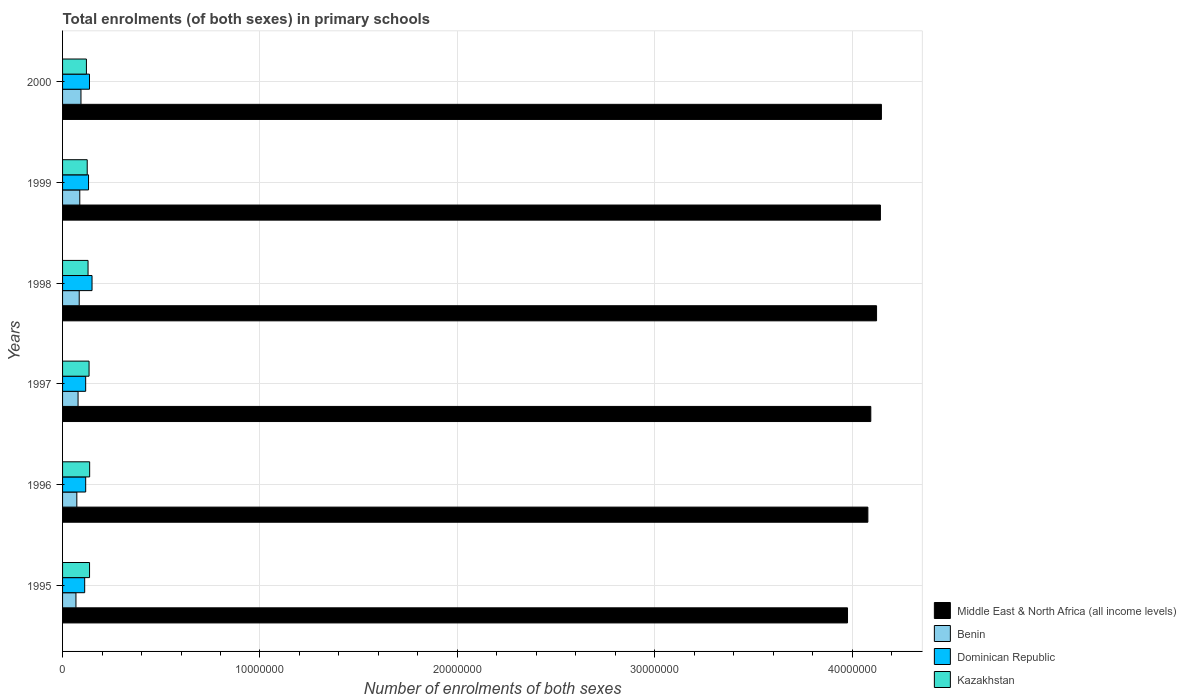How many different coloured bars are there?
Provide a succinct answer. 4. Are the number of bars per tick equal to the number of legend labels?
Give a very brief answer. Yes. How many bars are there on the 1st tick from the bottom?
Keep it short and to the point. 4. What is the label of the 6th group of bars from the top?
Make the answer very short. 1995. In how many cases, is the number of bars for a given year not equal to the number of legend labels?
Offer a terse response. 0. What is the number of enrolments in primary schools in Middle East & North Africa (all income levels) in 1999?
Ensure brevity in your answer.  4.14e+07. Across all years, what is the maximum number of enrolments in primary schools in Kazakhstan?
Offer a very short reply. 1.37e+06. Across all years, what is the minimum number of enrolments in primary schools in Dominican Republic?
Provide a succinct answer. 1.12e+06. What is the total number of enrolments in primary schools in Dominican Republic in the graph?
Give a very brief answer. 7.63e+06. What is the difference between the number of enrolments in primary schools in Middle East & North Africa (all income levels) in 1999 and that in 2000?
Your answer should be compact. -5.08e+04. What is the difference between the number of enrolments in primary schools in Middle East & North Africa (all income levels) in 1995 and the number of enrolments in primary schools in Kazakhstan in 1997?
Make the answer very short. 3.84e+07. What is the average number of enrolments in primary schools in Dominican Republic per year?
Provide a succinct answer. 1.27e+06. In the year 2000, what is the difference between the number of enrolments in primary schools in Dominican Republic and number of enrolments in primary schools in Benin?
Offer a very short reply. 4.31e+05. In how many years, is the number of enrolments in primary schools in Benin greater than 30000000 ?
Your answer should be very brief. 0. What is the ratio of the number of enrolments in primary schools in Kazakhstan in 1998 to that in 1999?
Give a very brief answer. 1.03. What is the difference between the highest and the second highest number of enrolments in primary schools in Kazakhstan?
Your answer should be very brief. 5534. What is the difference between the highest and the lowest number of enrolments in primary schools in Kazakhstan?
Your answer should be very brief. 1.64e+05. Is it the case that in every year, the sum of the number of enrolments in primary schools in Dominican Republic and number of enrolments in primary schools in Middle East & North Africa (all income levels) is greater than the sum of number of enrolments in primary schools in Kazakhstan and number of enrolments in primary schools in Benin?
Offer a very short reply. Yes. What does the 1st bar from the top in 2000 represents?
Offer a terse response. Kazakhstan. What does the 3rd bar from the bottom in 1999 represents?
Keep it short and to the point. Dominican Republic. Is it the case that in every year, the sum of the number of enrolments in primary schools in Benin and number of enrolments in primary schools in Dominican Republic is greater than the number of enrolments in primary schools in Middle East & North Africa (all income levels)?
Offer a terse response. No. What is the difference between two consecutive major ticks on the X-axis?
Your response must be concise. 1.00e+07. Are the values on the major ticks of X-axis written in scientific E-notation?
Make the answer very short. No. Does the graph contain any zero values?
Give a very brief answer. No. Does the graph contain grids?
Offer a terse response. Yes. How are the legend labels stacked?
Your answer should be compact. Vertical. What is the title of the graph?
Provide a succinct answer. Total enrolments (of both sexes) in primary schools. Does "Senegal" appear as one of the legend labels in the graph?
Keep it short and to the point. No. What is the label or title of the X-axis?
Make the answer very short. Number of enrolments of both sexes. What is the label or title of the Y-axis?
Ensure brevity in your answer.  Years. What is the Number of enrolments of both sexes of Middle East & North Africa (all income levels) in 1995?
Your answer should be very brief. 3.98e+07. What is the Number of enrolments of both sexes in Benin in 1995?
Your response must be concise. 6.78e+05. What is the Number of enrolments of both sexes in Dominican Republic in 1995?
Offer a very short reply. 1.12e+06. What is the Number of enrolments of both sexes in Kazakhstan in 1995?
Offer a terse response. 1.37e+06. What is the Number of enrolments of both sexes in Middle East & North Africa (all income levels) in 1996?
Your answer should be very brief. 4.08e+07. What is the Number of enrolments of both sexes of Benin in 1996?
Offer a very short reply. 7.22e+05. What is the Number of enrolments of both sexes of Dominican Republic in 1996?
Give a very brief answer. 1.17e+06. What is the Number of enrolments of both sexes in Kazakhstan in 1996?
Make the answer very short. 1.37e+06. What is the Number of enrolments of both sexes of Middle East & North Africa (all income levels) in 1997?
Your answer should be compact. 4.09e+07. What is the Number of enrolments of both sexes in Benin in 1997?
Your answer should be compact. 7.85e+05. What is the Number of enrolments of both sexes of Dominican Republic in 1997?
Provide a short and direct response. 1.17e+06. What is the Number of enrolments of both sexes in Kazakhstan in 1997?
Provide a succinct answer. 1.34e+06. What is the Number of enrolments of both sexes of Middle East & North Africa (all income levels) in 1998?
Ensure brevity in your answer.  4.12e+07. What is the Number of enrolments of both sexes of Benin in 1998?
Offer a terse response. 8.43e+05. What is the Number of enrolments of both sexes of Dominican Republic in 1998?
Keep it short and to the point. 1.49e+06. What is the Number of enrolments of both sexes of Kazakhstan in 1998?
Offer a terse response. 1.29e+06. What is the Number of enrolments of both sexes of Middle East & North Africa (all income levels) in 1999?
Offer a terse response. 4.14e+07. What is the Number of enrolments of both sexes of Benin in 1999?
Offer a terse response. 8.72e+05. What is the Number of enrolments of both sexes of Dominican Republic in 1999?
Your answer should be compact. 1.32e+06. What is the Number of enrolments of both sexes in Kazakhstan in 1999?
Your response must be concise. 1.25e+06. What is the Number of enrolments of both sexes of Middle East & North Africa (all income levels) in 2000?
Your response must be concise. 4.15e+07. What is the Number of enrolments of both sexes in Benin in 2000?
Offer a very short reply. 9.32e+05. What is the Number of enrolments of both sexes of Dominican Republic in 2000?
Make the answer very short. 1.36e+06. What is the Number of enrolments of both sexes in Kazakhstan in 2000?
Give a very brief answer. 1.21e+06. Across all years, what is the maximum Number of enrolments of both sexes of Middle East & North Africa (all income levels)?
Offer a terse response. 4.15e+07. Across all years, what is the maximum Number of enrolments of both sexes in Benin?
Your answer should be compact. 9.32e+05. Across all years, what is the maximum Number of enrolments of both sexes in Dominican Republic?
Your response must be concise. 1.49e+06. Across all years, what is the maximum Number of enrolments of both sexes of Kazakhstan?
Your response must be concise. 1.37e+06. Across all years, what is the minimum Number of enrolments of both sexes in Middle East & North Africa (all income levels)?
Ensure brevity in your answer.  3.98e+07. Across all years, what is the minimum Number of enrolments of both sexes in Benin?
Provide a short and direct response. 6.78e+05. Across all years, what is the minimum Number of enrolments of both sexes in Dominican Republic?
Give a very brief answer. 1.12e+06. Across all years, what is the minimum Number of enrolments of both sexes in Kazakhstan?
Offer a very short reply. 1.21e+06. What is the total Number of enrolments of both sexes of Middle East & North Africa (all income levels) in the graph?
Make the answer very short. 2.46e+08. What is the total Number of enrolments of both sexes in Benin in the graph?
Provide a short and direct response. 4.83e+06. What is the total Number of enrolments of both sexes of Dominican Republic in the graph?
Provide a succinct answer. 7.63e+06. What is the total Number of enrolments of both sexes in Kazakhstan in the graph?
Provide a short and direct response. 7.83e+06. What is the difference between the Number of enrolments of both sexes of Middle East & North Africa (all income levels) in 1995 and that in 1996?
Your answer should be compact. -1.03e+06. What is the difference between the Number of enrolments of both sexes of Benin in 1995 and that in 1996?
Ensure brevity in your answer.  -4.43e+04. What is the difference between the Number of enrolments of both sexes of Dominican Republic in 1995 and that in 1996?
Make the answer very short. -5.05e+04. What is the difference between the Number of enrolments of both sexes in Kazakhstan in 1995 and that in 1996?
Make the answer very short. -5534. What is the difference between the Number of enrolments of both sexes of Middle East & North Africa (all income levels) in 1995 and that in 1997?
Provide a short and direct response. -1.18e+06. What is the difference between the Number of enrolments of both sexes in Benin in 1995 and that in 1997?
Provide a succinct answer. -1.07e+05. What is the difference between the Number of enrolments of both sexes in Dominican Republic in 1995 and that in 1997?
Offer a terse response. -4.94e+04. What is the difference between the Number of enrolments of both sexes in Kazakhstan in 1995 and that in 1997?
Offer a terse response. 2.50e+04. What is the difference between the Number of enrolments of both sexes in Middle East & North Africa (all income levels) in 1995 and that in 1998?
Provide a succinct answer. -1.47e+06. What is the difference between the Number of enrolments of both sexes of Benin in 1995 and that in 1998?
Offer a terse response. -1.65e+05. What is the difference between the Number of enrolments of both sexes in Dominican Republic in 1995 and that in 1998?
Provide a short and direct response. -3.72e+05. What is the difference between the Number of enrolments of both sexes in Kazakhstan in 1995 and that in 1998?
Your answer should be compact. 7.63e+04. What is the difference between the Number of enrolments of both sexes of Middle East & North Africa (all income levels) in 1995 and that in 1999?
Your response must be concise. -1.67e+06. What is the difference between the Number of enrolments of both sexes of Benin in 1995 and that in 1999?
Give a very brief answer. -1.94e+05. What is the difference between the Number of enrolments of both sexes in Dominican Republic in 1995 and that in 1999?
Provide a short and direct response. -1.94e+05. What is the difference between the Number of enrolments of both sexes of Kazakhstan in 1995 and that in 1999?
Offer a very short reply. 1.18e+05. What is the difference between the Number of enrolments of both sexes of Middle East & North Africa (all income levels) in 1995 and that in 2000?
Your answer should be compact. -1.72e+06. What is the difference between the Number of enrolments of both sexes in Benin in 1995 and that in 2000?
Offer a very short reply. -2.55e+05. What is the difference between the Number of enrolments of both sexes in Dominican Republic in 1995 and that in 2000?
Provide a short and direct response. -2.43e+05. What is the difference between the Number of enrolments of both sexes of Kazakhstan in 1995 and that in 2000?
Keep it short and to the point. 1.59e+05. What is the difference between the Number of enrolments of both sexes in Middle East & North Africa (all income levels) in 1996 and that in 1997?
Ensure brevity in your answer.  -1.48e+05. What is the difference between the Number of enrolments of both sexes of Benin in 1996 and that in 1997?
Your answer should be compact. -6.27e+04. What is the difference between the Number of enrolments of both sexes of Dominican Republic in 1996 and that in 1997?
Offer a terse response. 1073. What is the difference between the Number of enrolments of both sexes of Kazakhstan in 1996 and that in 1997?
Ensure brevity in your answer.  3.06e+04. What is the difference between the Number of enrolments of both sexes in Middle East & North Africa (all income levels) in 1996 and that in 1998?
Your answer should be compact. -4.40e+05. What is the difference between the Number of enrolments of both sexes of Benin in 1996 and that in 1998?
Ensure brevity in your answer.  -1.21e+05. What is the difference between the Number of enrolments of both sexes of Dominican Republic in 1996 and that in 1998?
Keep it short and to the point. -3.21e+05. What is the difference between the Number of enrolments of both sexes of Kazakhstan in 1996 and that in 1998?
Keep it short and to the point. 8.18e+04. What is the difference between the Number of enrolments of both sexes of Middle East & North Africa (all income levels) in 1996 and that in 1999?
Make the answer very short. -6.35e+05. What is the difference between the Number of enrolments of both sexes of Benin in 1996 and that in 1999?
Your response must be concise. -1.50e+05. What is the difference between the Number of enrolments of both sexes in Dominican Republic in 1996 and that in 1999?
Offer a very short reply. -1.44e+05. What is the difference between the Number of enrolments of both sexes of Kazakhstan in 1996 and that in 1999?
Provide a succinct answer. 1.24e+05. What is the difference between the Number of enrolments of both sexes in Middle East & North Africa (all income levels) in 1996 and that in 2000?
Your answer should be very brief. -6.86e+05. What is the difference between the Number of enrolments of both sexes of Benin in 1996 and that in 2000?
Provide a short and direct response. -2.10e+05. What is the difference between the Number of enrolments of both sexes of Dominican Republic in 1996 and that in 2000?
Make the answer very short. -1.92e+05. What is the difference between the Number of enrolments of both sexes in Kazakhstan in 1996 and that in 2000?
Your response must be concise. 1.64e+05. What is the difference between the Number of enrolments of both sexes of Middle East & North Africa (all income levels) in 1997 and that in 1998?
Ensure brevity in your answer.  -2.92e+05. What is the difference between the Number of enrolments of both sexes in Benin in 1997 and that in 1998?
Ensure brevity in your answer.  -5.85e+04. What is the difference between the Number of enrolments of both sexes in Dominican Republic in 1997 and that in 1998?
Your response must be concise. -3.22e+05. What is the difference between the Number of enrolments of both sexes in Kazakhstan in 1997 and that in 1998?
Offer a very short reply. 5.12e+04. What is the difference between the Number of enrolments of both sexes of Middle East & North Africa (all income levels) in 1997 and that in 1999?
Make the answer very short. -4.87e+05. What is the difference between the Number of enrolments of both sexes in Benin in 1997 and that in 1999?
Make the answer very short. -8.73e+04. What is the difference between the Number of enrolments of both sexes of Dominican Republic in 1997 and that in 1999?
Offer a terse response. -1.45e+05. What is the difference between the Number of enrolments of both sexes of Kazakhstan in 1997 and that in 1999?
Your response must be concise. 9.31e+04. What is the difference between the Number of enrolments of both sexes of Middle East & North Africa (all income levels) in 1997 and that in 2000?
Provide a short and direct response. -5.38e+05. What is the difference between the Number of enrolments of both sexes in Benin in 1997 and that in 2000?
Provide a succinct answer. -1.48e+05. What is the difference between the Number of enrolments of both sexes of Dominican Republic in 1997 and that in 2000?
Make the answer very short. -1.93e+05. What is the difference between the Number of enrolments of both sexes in Kazakhstan in 1997 and that in 2000?
Ensure brevity in your answer.  1.34e+05. What is the difference between the Number of enrolments of both sexes of Middle East & North Africa (all income levels) in 1998 and that in 1999?
Provide a succinct answer. -1.95e+05. What is the difference between the Number of enrolments of both sexes in Benin in 1998 and that in 1999?
Give a very brief answer. -2.89e+04. What is the difference between the Number of enrolments of both sexes in Dominican Republic in 1998 and that in 1999?
Your response must be concise. 1.77e+05. What is the difference between the Number of enrolments of both sexes in Kazakhstan in 1998 and that in 1999?
Make the answer very short. 4.19e+04. What is the difference between the Number of enrolments of both sexes of Middle East & North Africa (all income levels) in 1998 and that in 2000?
Provide a short and direct response. -2.46e+05. What is the difference between the Number of enrolments of both sexes in Benin in 1998 and that in 2000?
Keep it short and to the point. -8.91e+04. What is the difference between the Number of enrolments of both sexes in Dominican Republic in 1998 and that in 2000?
Provide a short and direct response. 1.29e+05. What is the difference between the Number of enrolments of both sexes in Kazakhstan in 1998 and that in 2000?
Your answer should be compact. 8.25e+04. What is the difference between the Number of enrolments of both sexes of Middle East & North Africa (all income levels) in 1999 and that in 2000?
Your answer should be compact. -5.08e+04. What is the difference between the Number of enrolments of both sexes in Benin in 1999 and that in 2000?
Offer a terse response. -6.02e+04. What is the difference between the Number of enrolments of both sexes in Dominican Republic in 1999 and that in 2000?
Provide a short and direct response. -4.83e+04. What is the difference between the Number of enrolments of both sexes in Kazakhstan in 1999 and that in 2000?
Keep it short and to the point. 4.06e+04. What is the difference between the Number of enrolments of both sexes of Middle East & North Africa (all income levels) in 1995 and the Number of enrolments of both sexes of Benin in 1996?
Offer a terse response. 3.90e+07. What is the difference between the Number of enrolments of both sexes in Middle East & North Africa (all income levels) in 1995 and the Number of enrolments of both sexes in Dominican Republic in 1996?
Offer a very short reply. 3.86e+07. What is the difference between the Number of enrolments of both sexes of Middle East & North Africa (all income levels) in 1995 and the Number of enrolments of both sexes of Kazakhstan in 1996?
Provide a short and direct response. 3.84e+07. What is the difference between the Number of enrolments of both sexes in Benin in 1995 and the Number of enrolments of both sexes in Dominican Republic in 1996?
Your answer should be compact. -4.94e+05. What is the difference between the Number of enrolments of both sexes of Benin in 1995 and the Number of enrolments of both sexes of Kazakhstan in 1996?
Provide a short and direct response. -6.95e+05. What is the difference between the Number of enrolments of both sexes in Dominican Republic in 1995 and the Number of enrolments of both sexes in Kazakhstan in 1996?
Keep it short and to the point. -2.52e+05. What is the difference between the Number of enrolments of both sexes of Middle East & North Africa (all income levels) in 1995 and the Number of enrolments of both sexes of Benin in 1997?
Your response must be concise. 3.90e+07. What is the difference between the Number of enrolments of both sexes in Middle East & North Africa (all income levels) in 1995 and the Number of enrolments of both sexes in Dominican Republic in 1997?
Provide a short and direct response. 3.86e+07. What is the difference between the Number of enrolments of both sexes of Middle East & North Africa (all income levels) in 1995 and the Number of enrolments of both sexes of Kazakhstan in 1997?
Your response must be concise. 3.84e+07. What is the difference between the Number of enrolments of both sexes of Benin in 1995 and the Number of enrolments of both sexes of Dominican Republic in 1997?
Provide a succinct answer. -4.93e+05. What is the difference between the Number of enrolments of both sexes of Benin in 1995 and the Number of enrolments of both sexes of Kazakhstan in 1997?
Give a very brief answer. -6.64e+05. What is the difference between the Number of enrolments of both sexes of Dominican Republic in 1995 and the Number of enrolments of both sexes of Kazakhstan in 1997?
Offer a terse response. -2.21e+05. What is the difference between the Number of enrolments of both sexes in Middle East & North Africa (all income levels) in 1995 and the Number of enrolments of both sexes in Benin in 1998?
Make the answer very short. 3.89e+07. What is the difference between the Number of enrolments of both sexes of Middle East & North Africa (all income levels) in 1995 and the Number of enrolments of both sexes of Dominican Republic in 1998?
Provide a short and direct response. 3.83e+07. What is the difference between the Number of enrolments of both sexes in Middle East & North Africa (all income levels) in 1995 and the Number of enrolments of both sexes in Kazakhstan in 1998?
Ensure brevity in your answer.  3.85e+07. What is the difference between the Number of enrolments of both sexes in Benin in 1995 and the Number of enrolments of both sexes in Dominican Republic in 1998?
Keep it short and to the point. -8.15e+05. What is the difference between the Number of enrolments of both sexes of Benin in 1995 and the Number of enrolments of both sexes of Kazakhstan in 1998?
Offer a very short reply. -6.13e+05. What is the difference between the Number of enrolments of both sexes in Dominican Republic in 1995 and the Number of enrolments of both sexes in Kazakhstan in 1998?
Give a very brief answer. -1.70e+05. What is the difference between the Number of enrolments of both sexes of Middle East & North Africa (all income levels) in 1995 and the Number of enrolments of both sexes of Benin in 1999?
Make the answer very short. 3.89e+07. What is the difference between the Number of enrolments of both sexes in Middle East & North Africa (all income levels) in 1995 and the Number of enrolments of both sexes in Dominican Republic in 1999?
Offer a very short reply. 3.84e+07. What is the difference between the Number of enrolments of both sexes of Middle East & North Africa (all income levels) in 1995 and the Number of enrolments of both sexes of Kazakhstan in 1999?
Provide a short and direct response. 3.85e+07. What is the difference between the Number of enrolments of both sexes of Benin in 1995 and the Number of enrolments of both sexes of Dominican Republic in 1999?
Make the answer very short. -6.37e+05. What is the difference between the Number of enrolments of both sexes in Benin in 1995 and the Number of enrolments of both sexes in Kazakhstan in 1999?
Your answer should be compact. -5.71e+05. What is the difference between the Number of enrolments of both sexes in Dominican Republic in 1995 and the Number of enrolments of both sexes in Kazakhstan in 1999?
Your answer should be very brief. -1.28e+05. What is the difference between the Number of enrolments of both sexes in Middle East & North Africa (all income levels) in 1995 and the Number of enrolments of both sexes in Benin in 2000?
Provide a succinct answer. 3.88e+07. What is the difference between the Number of enrolments of both sexes of Middle East & North Africa (all income levels) in 1995 and the Number of enrolments of both sexes of Dominican Republic in 2000?
Your answer should be very brief. 3.84e+07. What is the difference between the Number of enrolments of both sexes of Middle East & North Africa (all income levels) in 1995 and the Number of enrolments of both sexes of Kazakhstan in 2000?
Keep it short and to the point. 3.86e+07. What is the difference between the Number of enrolments of both sexes of Benin in 1995 and the Number of enrolments of both sexes of Dominican Republic in 2000?
Provide a short and direct response. -6.86e+05. What is the difference between the Number of enrolments of both sexes in Benin in 1995 and the Number of enrolments of both sexes in Kazakhstan in 2000?
Your answer should be very brief. -5.30e+05. What is the difference between the Number of enrolments of both sexes of Dominican Republic in 1995 and the Number of enrolments of both sexes of Kazakhstan in 2000?
Your response must be concise. -8.73e+04. What is the difference between the Number of enrolments of both sexes in Middle East & North Africa (all income levels) in 1996 and the Number of enrolments of both sexes in Benin in 1997?
Give a very brief answer. 4.00e+07. What is the difference between the Number of enrolments of both sexes in Middle East & North Africa (all income levels) in 1996 and the Number of enrolments of both sexes in Dominican Republic in 1997?
Provide a succinct answer. 3.96e+07. What is the difference between the Number of enrolments of both sexes in Middle East & North Africa (all income levels) in 1996 and the Number of enrolments of both sexes in Kazakhstan in 1997?
Provide a short and direct response. 3.95e+07. What is the difference between the Number of enrolments of both sexes in Benin in 1996 and the Number of enrolments of both sexes in Dominican Republic in 1997?
Give a very brief answer. -4.48e+05. What is the difference between the Number of enrolments of both sexes in Benin in 1996 and the Number of enrolments of both sexes in Kazakhstan in 1997?
Your answer should be compact. -6.20e+05. What is the difference between the Number of enrolments of both sexes in Dominican Republic in 1996 and the Number of enrolments of both sexes in Kazakhstan in 1997?
Make the answer very short. -1.71e+05. What is the difference between the Number of enrolments of both sexes of Middle East & North Africa (all income levels) in 1996 and the Number of enrolments of both sexes of Benin in 1998?
Ensure brevity in your answer.  4.00e+07. What is the difference between the Number of enrolments of both sexes of Middle East & North Africa (all income levels) in 1996 and the Number of enrolments of both sexes of Dominican Republic in 1998?
Your response must be concise. 3.93e+07. What is the difference between the Number of enrolments of both sexes of Middle East & North Africa (all income levels) in 1996 and the Number of enrolments of both sexes of Kazakhstan in 1998?
Your answer should be very brief. 3.95e+07. What is the difference between the Number of enrolments of both sexes in Benin in 1996 and the Number of enrolments of both sexes in Dominican Republic in 1998?
Make the answer very short. -7.70e+05. What is the difference between the Number of enrolments of both sexes of Benin in 1996 and the Number of enrolments of both sexes of Kazakhstan in 1998?
Offer a very short reply. -5.69e+05. What is the difference between the Number of enrolments of both sexes in Dominican Republic in 1996 and the Number of enrolments of both sexes in Kazakhstan in 1998?
Provide a succinct answer. -1.19e+05. What is the difference between the Number of enrolments of both sexes of Middle East & North Africa (all income levels) in 1996 and the Number of enrolments of both sexes of Benin in 1999?
Offer a very short reply. 3.99e+07. What is the difference between the Number of enrolments of both sexes in Middle East & North Africa (all income levels) in 1996 and the Number of enrolments of both sexes in Dominican Republic in 1999?
Provide a succinct answer. 3.95e+07. What is the difference between the Number of enrolments of both sexes of Middle East & North Africa (all income levels) in 1996 and the Number of enrolments of both sexes of Kazakhstan in 1999?
Provide a succinct answer. 3.95e+07. What is the difference between the Number of enrolments of both sexes of Benin in 1996 and the Number of enrolments of both sexes of Dominican Republic in 1999?
Provide a short and direct response. -5.93e+05. What is the difference between the Number of enrolments of both sexes in Benin in 1996 and the Number of enrolments of both sexes in Kazakhstan in 1999?
Provide a succinct answer. -5.27e+05. What is the difference between the Number of enrolments of both sexes in Dominican Republic in 1996 and the Number of enrolments of both sexes in Kazakhstan in 1999?
Your response must be concise. -7.74e+04. What is the difference between the Number of enrolments of both sexes in Middle East & North Africa (all income levels) in 1996 and the Number of enrolments of both sexes in Benin in 2000?
Provide a succinct answer. 3.99e+07. What is the difference between the Number of enrolments of both sexes of Middle East & North Africa (all income levels) in 1996 and the Number of enrolments of both sexes of Dominican Republic in 2000?
Give a very brief answer. 3.94e+07. What is the difference between the Number of enrolments of both sexes in Middle East & North Africa (all income levels) in 1996 and the Number of enrolments of both sexes in Kazakhstan in 2000?
Give a very brief answer. 3.96e+07. What is the difference between the Number of enrolments of both sexes of Benin in 1996 and the Number of enrolments of both sexes of Dominican Republic in 2000?
Your response must be concise. -6.41e+05. What is the difference between the Number of enrolments of both sexes of Benin in 1996 and the Number of enrolments of both sexes of Kazakhstan in 2000?
Your answer should be very brief. -4.86e+05. What is the difference between the Number of enrolments of both sexes in Dominican Republic in 1996 and the Number of enrolments of both sexes in Kazakhstan in 2000?
Your answer should be compact. -3.68e+04. What is the difference between the Number of enrolments of both sexes of Middle East & North Africa (all income levels) in 1997 and the Number of enrolments of both sexes of Benin in 1998?
Give a very brief answer. 4.01e+07. What is the difference between the Number of enrolments of both sexes of Middle East & North Africa (all income levels) in 1997 and the Number of enrolments of both sexes of Dominican Republic in 1998?
Give a very brief answer. 3.95e+07. What is the difference between the Number of enrolments of both sexes of Middle East & North Africa (all income levels) in 1997 and the Number of enrolments of both sexes of Kazakhstan in 1998?
Make the answer very short. 3.97e+07. What is the difference between the Number of enrolments of both sexes of Benin in 1997 and the Number of enrolments of both sexes of Dominican Republic in 1998?
Your response must be concise. -7.08e+05. What is the difference between the Number of enrolments of both sexes of Benin in 1997 and the Number of enrolments of both sexes of Kazakhstan in 1998?
Ensure brevity in your answer.  -5.06e+05. What is the difference between the Number of enrolments of both sexes in Dominican Republic in 1997 and the Number of enrolments of both sexes in Kazakhstan in 1998?
Offer a very short reply. -1.20e+05. What is the difference between the Number of enrolments of both sexes in Middle East & North Africa (all income levels) in 1997 and the Number of enrolments of both sexes in Benin in 1999?
Provide a short and direct response. 4.01e+07. What is the difference between the Number of enrolments of both sexes in Middle East & North Africa (all income levels) in 1997 and the Number of enrolments of both sexes in Dominican Republic in 1999?
Provide a succinct answer. 3.96e+07. What is the difference between the Number of enrolments of both sexes of Middle East & North Africa (all income levels) in 1997 and the Number of enrolments of both sexes of Kazakhstan in 1999?
Your answer should be compact. 3.97e+07. What is the difference between the Number of enrolments of both sexes in Benin in 1997 and the Number of enrolments of both sexes in Dominican Republic in 1999?
Provide a succinct answer. -5.30e+05. What is the difference between the Number of enrolments of both sexes in Benin in 1997 and the Number of enrolments of both sexes in Kazakhstan in 1999?
Your answer should be compact. -4.64e+05. What is the difference between the Number of enrolments of both sexes in Dominican Republic in 1997 and the Number of enrolments of both sexes in Kazakhstan in 1999?
Your answer should be very brief. -7.85e+04. What is the difference between the Number of enrolments of both sexes in Middle East & North Africa (all income levels) in 1997 and the Number of enrolments of both sexes in Benin in 2000?
Keep it short and to the point. 4.00e+07. What is the difference between the Number of enrolments of both sexes in Middle East & North Africa (all income levels) in 1997 and the Number of enrolments of both sexes in Dominican Republic in 2000?
Your response must be concise. 3.96e+07. What is the difference between the Number of enrolments of both sexes in Middle East & North Africa (all income levels) in 1997 and the Number of enrolments of both sexes in Kazakhstan in 2000?
Give a very brief answer. 3.97e+07. What is the difference between the Number of enrolments of both sexes in Benin in 1997 and the Number of enrolments of both sexes in Dominican Republic in 2000?
Provide a short and direct response. -5.79e+05. What is the difference between the Number of enrolments of both sexes in Benin in 1997 and the Number of enrolments of both sexes in Kazakhstan in 2000?
Your answer should be very brief. -4.23e+05. What is the difference between the Number of enrolments of both sexes in Dominican Republic in 1997 and the Number of enrolments of both sexes in Kazakhstan in 2000?
Provide a succinct answer. -3.79e+04. What is the difference between the Number of enrolments of both sexes in Middle East & North Africa (all income levels) in 1998 and the Number of enrolments of both sexes in Benin in 1999?
Your response must be concise. 4.04e+07. What is the difference between the Number of enrolments of both sexes of Middle East & North Africa (all income levels) in 1998 and the Number of enrolments of both sexes of Dominican Republic in 1999?
Make the answer very short. 3.99e+07. What is the difference between the Number of enrolments of both sexes of Middle East & North Africa (all income levels) in 1998 and the Number of enrolments of both sexes of Kazakhstan in 1999?
Make the answer very short. 4.00e+07. What is the difference between the Number of enrolments of both sexes of Benin in 1998 and the Number of enrolments of both sexes of Dominican Republic in 1999?
Provide a succinct answer. -4.72e+05. What is the difference between the Number of enrolments of both sexes in Benin in 1998 and the Number of enrolments of both sexes in Kazakhstan in 1999?
Keep it short and to the point. -4.06e+05. What is the difference between the Number of enrolments of both sexes of Dominican Republic in 1998 and the Number of enrolments of both sexes of Kazakhstan in 1999?
Provide a short and direct response. 2.44e+05. What is the difference between the Number of enrolments of both sexes of Middle East & North Africa (all income levels) in 1998 and the Number of enrolments of both sexes of Benin in 2000?
Make the answer very short. 4.03e+07. What is the difference between the Number of enrolments of both sexes of Middle East & North Africa (all income levels) in 1998 and the Number of enrolments of both sexes of Dominican Republic in 2000?
Ensure brevity in your answer.  3.99e+07. What is the difference between the Number of enrolments of both sexes in Middle East & North Africa (all income levels) in 1998 and the Number of enrolments of both sexes in Kazakhstan in 2000?
Make the answer very short. 4.00e+07. What is the difference between the Number of enrolments of both sexes in Benin in 1998 and the Number of enrolments of both sexes in Dominican Republic in 2000?
Provide a short and direct response. -5.20e+05. What is the difference between the Number of enrolments of both sexes of Benin in 1998 and the Number of enrolments of both sexes of Kazakhstan in 2000?
Provide a short and direct response. -3.65e+05. What is the difference between the Number of enrolments of both sexes of Dominican Republic in 1998 and the Number of enrolments of both sexes of Kazakhstan in 2000?
Make the answer very short. 2.84e+05. What is the difference between the Number of enrolments of both sexes in Middle East & North Africa (all income levels) in 1999 and the Number of enrolments of both sexes in Benin in 2000?
Provide a succinct answer. 4.05e+07. What is the difference between the Number of enrolments of both sexes in Middle East & North Africa (all income levels) in 1999 and the Number of enrolments of both sexes in Dominican Republic in 2000?
Keep it short and to the point. 4.01e+07. What is the difference between the Number of enrolments of both sexes of Middle East & North Africa (all income levels) in 1999 and the Number of enrolments of both sexes of Kazakhstan in 2000?
Offer a very short reply. 4.02e+07. What is the difference between the Number of enrolments of both sexes in Benin in 1999 and the Number of enrolments of both sexes in Dominican Republic in 2000?
Ensure brevity in your answer.  -4.91e+05. What is the difference between the Number of enrolments of both sexes of Benin in 1999 and the Number of enrolments of both sexes of Kazakhstan in 2000?
Your answer should be compact. -3.36e+05. What is the difference between the Number of enrolments of both sexes of Dominican Republic in 1999 and the Number of enrolments of both sexes of Kazakhstan in 2000?
Your answer should be compact. 1.07e+05. What is the average Number of enrolments of both sexes in Middle East & North Africa (all income levels) per year?
Offer a terse response. 4.09e+07. What is the average Number of enrolments of both sexes in Benin per year?
Your answer should be very brief. 8.05e+05. What is the average Number of enrolments of both sexes of Dominican Republic per year?
Provide a short and direct response. 1.27e+06. What is the average Number of enrolments of both sexes of Kazakhstan per year?
Keep it short and to the point. 1.30e+06. In the year 1995, what is the difference between the Number of enrolments of both sexes in Middle East & North Africa (all income levels) and Number of enrolments of both sexes in Benin?
Provide a succinct answer. 3.91e+07. In the year 1995, what is the difference between the Number of enrolments of both sexes in Middle East & North Africa (all income levels) and Number of enrolments of both sexes in Dominican Republic?
Offer a very short reply. 3.86e+07. In the year 1995, what is the difference between the Number of enrolments of both sexes in Middle East & North Africa (all income levels) and Number of enrolments of both sexes in Kazakhstan?
Offer a terse response. 3.84e+07. In the year 1995, what is the difference between the Number of enrolments of both sexes of Benin and Number of enrolments of both sexes of Dominican Republic?
Offer a very short reply. -4.43e+05. In the year 1995, what is the difference between the Number of enrolments of both sexes of Benin and Number of enrolments of both sexes of Kazakhstan?
Your answer should be very brief. -6.89e+05. In the year 1995, what is the difference between the Number of enrolments of both sexes in Dominican Republic and Number of enrolments of both sexes in Kazakhstan?
Ensure brevity in your answer.  -2.46e+05. In the year 1996, what is the difference between the Number of enrolments of both sexes of Middle East & North Africa (all income levels) and Number of enrolments of both sexes of Benin?
Offer a terse response. 4.01e+07. In the year 1996, what is the difference between the Number of enrolments of both sexes in Middle East & North Africa (all income levels) and Number of enrolments of both sexes in Dominican Republic?
Make the answer very short. 3.96e+07. In the year 1996, what is the difference between the Number of enrolments of both sexes of Middle East & North Africa (all income levels) and Number of enrolments of both sexes of Kazakhstan?
Provide a succinct answer. 3.94e+07. In the year 1996, what is the difference between the Number of enrolments of both sexes of Benin and Number of enrolments of both sexes of Dominican Republic?
Keep it short and to the point. -4.49e+05. In the year 1996, what is the difference between the Number of enrolments of both sexes of Benin and Number of enrolments of both sexes of Kazakhstan?
Your response must be concise. -6.50e+05. In the year 1996, what is the difference between the Number of enrolments of both sexes of Dominican Republic and Number of enrolments of both sexes of Kazakhstan?
Your answer should be compact. -2.01e+05. In the year 1997, what is the difference between the Number of enrolments of both sexes of Middle East & North Africa (all income levels) and Number of enrolments of both sexes of Benin?
Provide a succinct answer. 4.02e+07. In the year 1997, what is the difference between the Number of enrolments of both sexes of Middle East & North Africa (all income levels) and Number of enrolments of both sexes of Dominican Republic?
Provide a succinct answer. 3.98e+07. In the year 1997, what is the difference between the Number of enrolments of both sexes in Middle East & North Africa (all income levels) and Number of enrolments of both sexes in Kazakhstan?
Your answer should be very brief. 3.96e+07. In the year 1997, what is the difference between the Number of enrolments of both sexes in Benin and Number of enrolments of both sexes in Dominican Republic?
Your answer should be compact. -3.86e+05. In the year 1997, what is the difference between the Number of enrolments of both sexes in Benin and Number of enrolments of both sexes in Kazakhstan?
Your answer should be very brief. -5.57e+05. In the year 1997, what is the difference between the Number of enrolments of both sexes in Dominican Republic and Number of enrolments of both sexes in Kazakhstan?
Ensure brevity in your answer.  -1.72e+05. In the year 1998, what is the difference between the Number of enrolments of both sexes of Middle East & North Africa (all income levels) and Number of enrolments of both sexes of Benin?
Offer a terse response. 4.04e+07. In the year 1998, what is the difference between the Number of enrolments of both sexes in Middle East & North Africa (all income levels) and Number of enrolments of both sexes in Dominican Republic?
Your answer should be very brief. 3.97e+07. In the year 1998, what is the difference between the Number of enrolments of both sexes in Middle East & North Africa (all income levels) and Number of enrolments of both sexes in Kazakhstan?
Give a very brief answer. 3.99e+07. In the year 1998, what is the difference between the Number of enrolments of both sexes in Benin and Number of enrolments of both sexes in Dominican Republic?
Your answer should be compact. -6.49e+05. In the year 1998, what is the difference between the Number of enrolments of both sexes in Benin and Number of enrolments of both sexes in Kazakhstan?
Your response must be concise. -4.47e+05. In the year 1998, what is the difference between the Number of enrolments of both sexes in Dominican Republic and Number of enrolments of both sexes in Kazakhstan?
Your answer should be compact. 2.02e+05. In the year 1999, what is the difference between the Number of enrolments of both sexes in Middle East & North Africa (all income levels) and Number of enrolments of both sexes in Benin?
Offer a terse response. 4.06e+07. In the year 1999, what is the difference between the Number of enrolments of both sexes of Middle East & North Africa (all income levels) and Number of enrolments of both sexes of Dominican Republic?
Give a very brief answer. 4.01e+07. In the year 1999, what is the difference between the Number of enrolments of both sexes of Middle East & North Africa (all income levels) and Number of enrolments of both sexes of Kazakhstan?
Your answer should be very brief. 4.02e+07. In the year 1999, what is the difference between the Number of enrolments of both sexes in Benin and Number of enrolments of both sexes in Dominican Republic?
Your response must be concise. -4.43e+05. In the year 1999, what is the difference between the Number of enrolments of both sexes of Benin and Number of enrolments of both sexes of Kazakhstan?
Ensure brevity in your answer.  -3.77e+05. In the year 1999, what is the difference between the Number of enrolments of both sexes of Dominican Republic and Number of enrolments of both sexes of Kazakhstan?
Offer a very short reply. 6.64e+04. In the year 2000, what is the difference between the Number of enrolments of both sexes in Middle East & North Africa (all income levels) and Number of enrolments of both sexes in Benin?
Provide a succinct answer. 4.05e+07. In the year 2000, what is the difference between the Number of enrolments of both sexes of Middle East & North Africa (all income levels) and Number of enrolments of both sexes of Dominican Republic?
Your answer should be very brief. 4.01e+07. In the year 2000, what is the difference between the Number of enrolments of both sexes in Middle East & North Africa (all income levels) and Number of enrolments of both sexes in Kazakhstan?
Your answer should be very brief. 4.03e+07. In the year 2000, what is the difference between the Number of enrolments of both sexes in Benin and Number of enrolments of both sexes in Dominican Republic?
Provide a short and direct response. -4.31e+05. In the year 2000, what is the difference between the Number of enrolments of both sexes in Benin and Number of enrolments of both sexes in Kazakhstan?
Offer a very short reply. -2.76e+05. In the year 2000, what is the difference between the Number of enrolments of both sexes of Dominican Republic and Number of enrolments of both sexes of Kazakhstan?
Provide a short and direct response. 1.55e+05. What is the ratio of the Number of enrolments of both sexes of Middle East & North Africa (all income levels) in 1995 to that in 1996?
Provide a succinct answer. 0.97. What is the ratio of the Number of enrolments of both sexes in Benin in 1995 to that in 1996?
Make the answer very short. 0.94. What is the ratio of the Number of enrolments of both sexes in Dominican Republic in 1995 to that in 1996?
Provide a succinct answer. 0.96. What is the ratio of the Number of enrolments of both sexes in Middle East & North Africa (all income levels) in 1995 to that in 1997?
Your response must be concise. 0.97. What is the ratio of the Number of enrolments of both sexes in Benin in 1995 to that in 1997?
Your response must be concise. 0.86. What is the ratio of the Number of enrolments of both sexes of Dominican Republic in 1995 to that in 1997?
Your response must be concise. 0.96. What is the ratio of the Number of enrolments of both sexes of Kazakhstan in 1995 to that in 1997?
Provide a succinct answer. 1.02. What is the ratio of the Number of enrolments of both sexes of Benin in 1995 to that in 1998?
Offer a terse response. 0.8. What is the ratio of the Number of enrolments of both sexes of Dominican Republic in 1995 to that in 1998?
Ensure brevity in your answer.  0.75. What is the ratio of the Number of enrolments of both sexes in Kazakhstan in 1995 to that in 1998?
Ensure brevity in your answer.  1.06. What is the ratio of the Number of enrolments of both sexes in Middle East & North Africa (all income levels) in 1995 to that in 1999?
Provide a short and direct response. 0.96. What is the ratio of the Number of enrolments of both sexes of Benin in 1995 to that in 1999?
Provide a succinct answer. 0.78. What is the ratio of the Number of enrolments of both sexes of Dominican Republic in 1995 to that in 1999?
Offer a terse response. 0.85. What is the ratio of the Number of enrolments of both sexes of Kazakhstan in 1995 to that in 1999?
Your answer should be compact. 1.09. What is the ratio of the Number of enrolments of both sexes in Middle East & North Africa (all income levels) in 1995 to that in 2000?
Make the answer very short. 0.96. What is the ratio of the Number of enrolments of both sexes of Benin in 1995 to that in 2000?
Make the answer very short. 0.73. What is the ratio of the Number of enrolments of both sexes in Dominican Republic in 1995 to that in 2000?
Your answer should be compact. 0.82. What is the ratio of the Number of enrolments of both sexes of Kazakhstan in 1995 to that in 2000?
Ensure brevity in your answer.  1.13. What is the ratio of the Number of enrolments of both sexes in Benin in 1996 to that in 1997?
Give a very brief answer. 0.92. What is the ratio of the Number of enrolments of both sexes in Dominican Republic in 1996 to that in 1997?
Offer a terse response. 1. What is the ratio of the Number of enrolments of both sexes in Kazakhstan in 1996 to that in 1997?
Your answer should be compact. 1.02. What is the ratio of the Number of enrolments of both sexes in Middle East & North Africa (all income levels) in 1996 to that in 1998?
Your answer should be very brief. 0.99. What is the ratio of the Number of enrolments of both sexes of Benin in 1996 to that in 1998?
Your response must be concise. 0.86. What is the ratio of the Number of enrolments of both sexes in Dominican Republic in 1996 to that in 1998?
Offer a very short reply. 0.78. What is the ratio of the Number of enrolments of both sexes of Kazakhstan in 1996 to that in 1998?
Your response must be concise. 1.06. What is the ratio of the Number of enrolments of both sexes in Middle East & North Africa (all income levels) in 1996 to that in 1999?
Your answer should be compact. 0.98. What is the ratio of the Number of enrolments of both sexes in Benin in 1996 to that in 1999?
Provide a succinct answer. 0.83. What is the ratio of the Number of enrolments of both sexes in Dominican Republic in 1996 to that in 1999?
Give a very brief answer. 0.89. What is the ratio of the Number of enrolments of both sexes in Kazakhstan in 1996 to that in 1999?
Give a very brief answer. 1.1. What is the ratio of the Number of enrolments of both sexes in Middle East & North Africa (all income levels) in 1996 to that in 2000?
Give a very brief answer. 0.98. What is the ratio of the Number of enrolments of both sexes of Benin in 1996 to that in 2000?
Make the answer very short. 0.77. What is the ratio of the Number of enrolments of both sexes of Dominican Republic in 1996 to that in 2000?
Provide a succinct answer. 0.86. What is the ratio of the Number of enrolments of both sexes in Kazakhstan in 1996 to that in 2000?
Ensure brevity in your answer.  1.14. What is the ratio of the Number of enrolments of both sexes in Benin in 1997 to that in 1998?
Keep it short and to the point. 0.93. What is the ratio of the Number of enrolments of both sexes in Dominican Republic in 1997 to that in 1998?
Your answer should be very brief. 0.78. What is the ratio of the Number of enrolments of both sexes of Kazakhstan in 1997 to that in 1998?
Your answer should be very brief. 1.04. What is the ratio of the Number of enrolments of both sexes in Benin in 1997 to that in 1999?
Offer a very short reply. 0.9. What is the ratio of the Number of enrolments of both sexes of Dominican Republic in 1997 to that in 1999?
Give a very brief answer. 0.89. What is the ratio of the Number of enrolments of both sexes of Kazakhstan in 1997 to that in 1999?
Keep it short and to the point. 1.07. What is the ratio of the Number of enrolments of both sexes in Benin in 1997 to that in 2000?
Your response must be concise. 0.84. What is the ratio of the Number of enrolments of both sexes of Dominican Republic in 1997 to that in 2000?
Your response must be concise. 0.86. What is the ratio of the Number of enrolments of both sexes in Kazakhstan in 1997 to that in 2000?
Offer a very short reply. 1.11. What is the ratio of the Number of enrolments of both sexes of Benin in 1998 to that in 1999?
Keep it short and to the point. 0.97. What is the ratio of the Number of enrolments of both sexes of Dominican Republic in 1998 to that in 1999?
Provide a short and direct response. 1.13. What is the ratio of the Number of enrolments of both sexes of Kazakhstan in 1998 to that in 1999?
Your response must be concise. 1.03. What is the ratio of the Number of enrolments of both sexes in Middle East & North Africa (all income levels) in 1998 to that in 2000?
Your answer should be compact. 0.99. What is the ratio of the Number of enrolments of both sexes in Benin in 1998 to that in 2000?
Offer a very short reply. 0.9. What is the ratio of the Number of enrolments of both sexes of Dominican Republic in 1998 to that in 2000?
Offer a very short reply. 1.09. What is the ratio of the Number of enrolments of both sexes of Kazakhstan in 1998 to that in 2000?
Provide a succinct answer. 1.07. What is the ratio of the Number of enrolments of both sexes in Benin in 1999 to that in 2000?
Your answer should be compact. 0.94. What is the ratio of the Number of enrolments of both sexes of Dominican Republic in 1999 to that in 2000?
Offer a terse response. 0.96. What is the ratio of the Number of enrolments of both sexes of Kazakhstan in 1999 to that in 2000?
Ensure brevity in your answer.  1.03. What is the difference between the highest and the second highest Number of enrolments of both sexes in Middle East & North Africa (all income levels)?
Keep it short and to the point. 5.08e+04. What is the difference between the highest and the second highest Number of enrolments of both sexes in Benin?
Make the answer very short. 6.02e+04. What is the difference between the highest and the second highest Number of enrolments of both sexes in Dominican Republic?
Your response must be concise. 1.29e+05. What is the difference between the highest and the second highest Number of enrolments of both sexes in Kazakhstan?
Keep it short and to the point. 5534. What is the difference between the highest and the lowest Number of enrolments of both sexes of Middle East & North Africa (all income levels)?
Keep it short and to the point. 1.72e+06. What is the difference between the highest and the lowest Number of enrolments of both sexes in Benin?
Provide a short and direct response. 2.55e+05. What is the difference between the highest and the lowest Number of enrolments of both sexes in Dominican Republic?
Ensure brevity in your answer.  3.72e+05. What is the difference between the highest and the lowest Number of enrolments of both sexes in Kazakhstan?
Your answer should be very brief. 1.64e+05. 